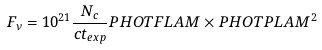Convert formula to latex. <formula><loc_0><loc_0><loc_500><loc_500>F _ { \nu } = 1 0 ^ { 2 1 } \frac { N _ { c } } { c t _ { e x p } } P H O T F L A M \times P H O T P L A M ^ { 2 }</formula> 